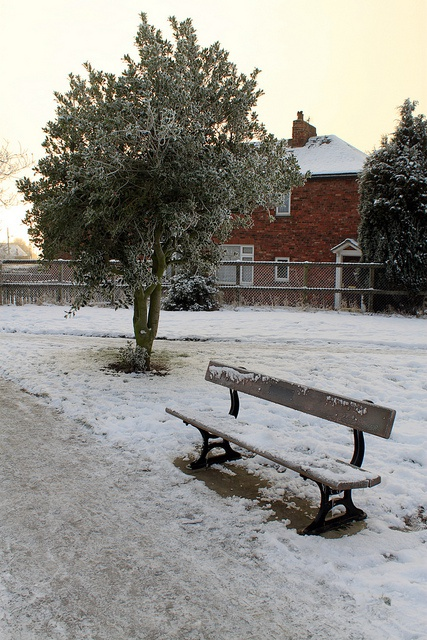Describe the objects in this image and their specific colors. I can see a bench in ivory, darkgray, gray, and black tones in this image. 